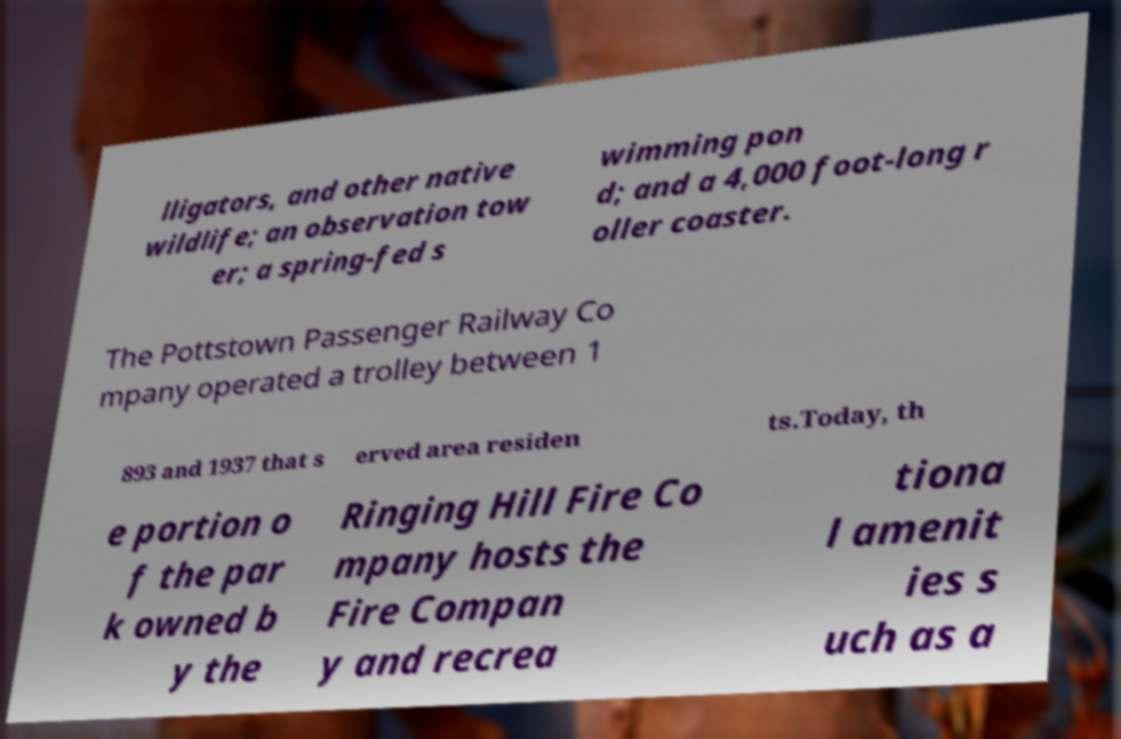Please identify and transcribe the text found in this image. lligators, and other native wildlife; an observation tow er; a spring-fed s wimming pon d; and a 4,000 foot-long r oller coaster. The Pottstown Passenger Railway Co mpany operated a trolley between 1 893 and 1937 that s erved area residen ts.Today, th e portion o f the par k owned b y the Ringing Hill Fire Co mpany hosts the Fire Compan y and recrea tiona l amenit ies s uch as a 